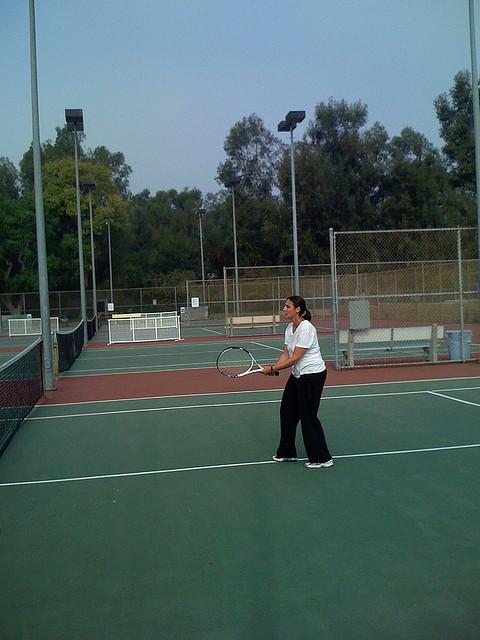What is the woman holding in her hands?
Answer briefly. Tennis racket. Is this game being played during the day?
Give a very brief answer. Yes. What can be seen far in the background?
Be succinct. Trees. What color is the court?
Short answer required. Green. Is this man casting a shadow?
Concise answer only. No. What color is the player's shirt?
Concise answer only. White. What sport is the man playing?
Short answer required. Tennis. What game is this woman playing?
Give a very brief answer. Tennis. Are there swings in the background?
Short answer required. No. What color are the players wearing?
Be succinct. Black and white. What hairstyle does the woman have?
Short answer required. Ponytail. What is the color of the court the woman is not standing in?
Write a very short answer. Red. 